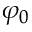<formula> <loc_0><loc_0><loc_500><loc_500>\varphi _ { 0 }</formula> 